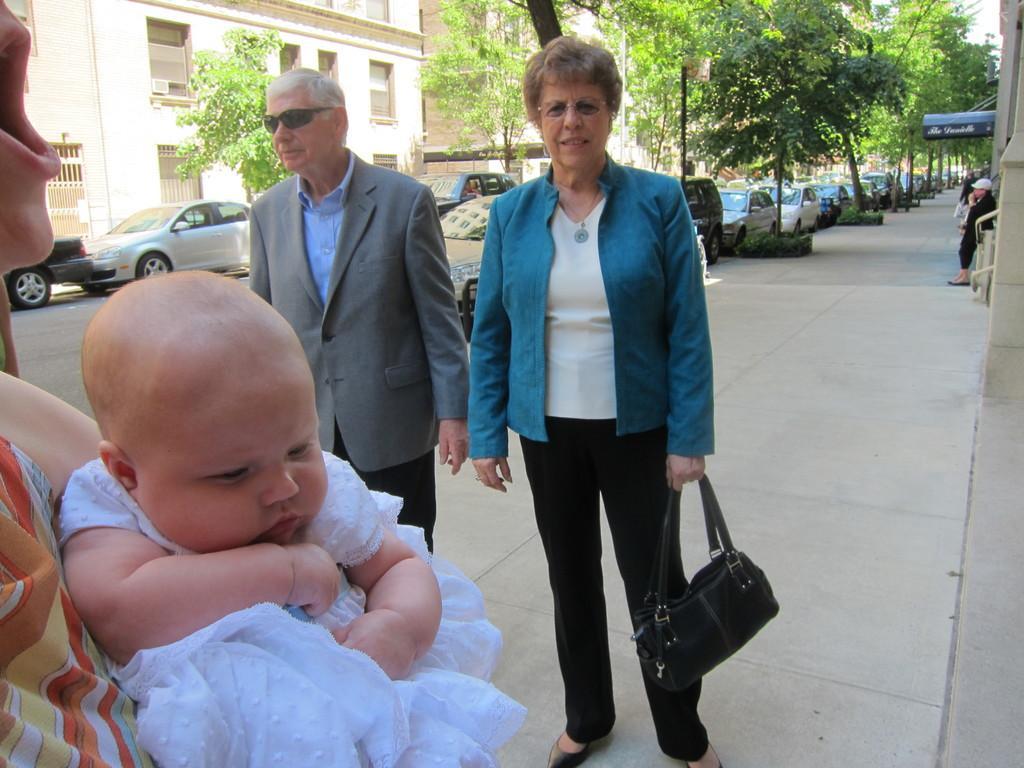Could you give a brief overview of what you see in this image? As we can see in the image there is a building, trees, cars and few people standing on road and the women who is standing here is holding black color bag. 